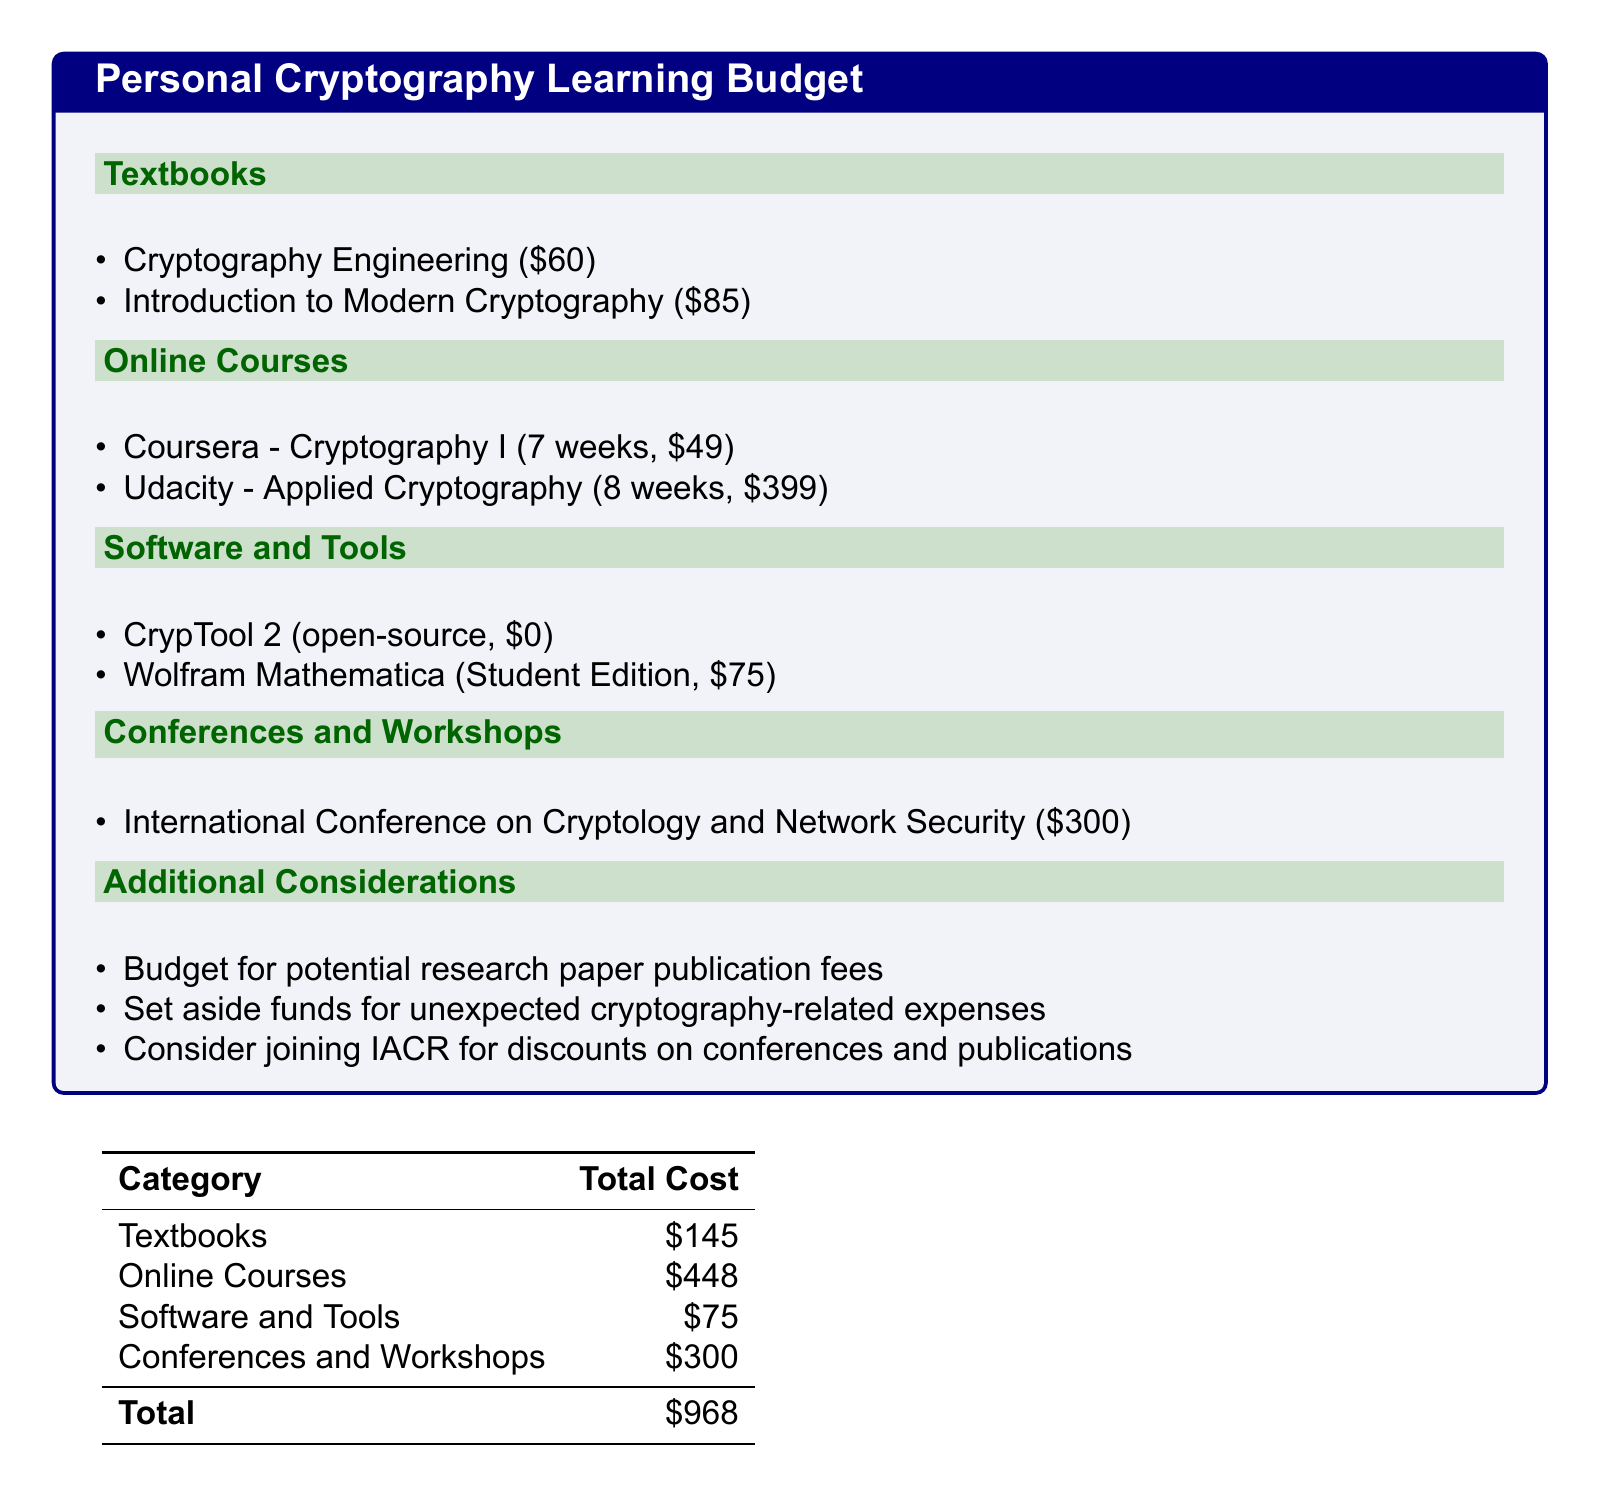what is the cost of "Cryptography Engineering"? The cost of "Cryptography Engineering" is listed as $60 in the document.
Answer: $60 how much does the "Applied Cryptography" course cost? The document states that the "Applied Cryptography" course costs $399.
Answer: $399 what is the total budget for Online Courses? The total budget for Online Courses is the sum of the individual course costs, which adds up to $448.
Answer: $448 how much does joining IACR potentially save? The document suggests considering joining IACR for discounts, but does not specify a dollar amount or percentage for savings.
Answer: discounts what is the total amount allocated for Conferences and Workshops? The budget allocated for Conferences and Workshops is detailed in the document as $300.
Answer: $300 how many weeks is the "Cryptography I" course? The document states that the "Cryptography I" course lasts for 7 weeks.
Answer: 7 weeks what is the total cost of all textbooks? The total cost of all textbooks is calculated in the document as $145.
Answer: $145 what is the total amount of the budget? The total budget is the sum of all categories listed in the document, which equals $968.
Answer: $968 what is the cost of the Student Edition of Wolfram Mathematica? The cost for the Student Edition of Wolfram Mathematica is mentioned as $75 in the document.
Answer: $75 